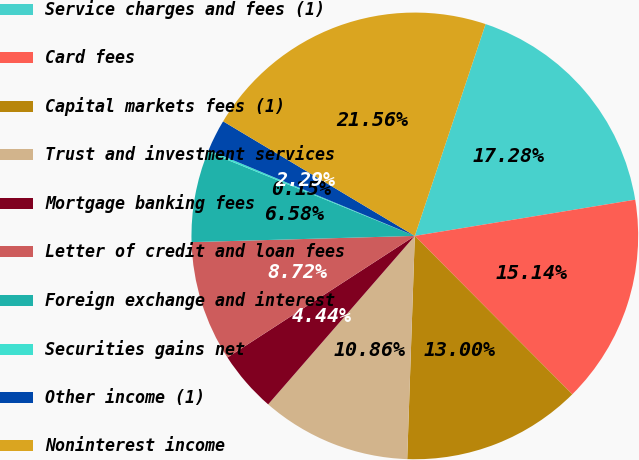<chart> <loc_0><loc_0><loc_500><loc_500><pie_chart><fcel>Service charges and fees (1)<fcel>Card fees<fcel>Capital markets fees (1)<fcel>Trust and investment services<fcel>Mortgage banking fees<fcel>Letter of credit and loan fees<fcel>Foreign exchange and interest<fcel>Securities gains net<fcel>Other income (1)<fcel>Noninterest income<nl><fcel>17.28%<fcel>15.14%<fcel>13.0%<fcel>10.86%<fcel>4.44%<fcel>8.72%<fcel>6.58%<fcel>0.15%<fcel>2.29%<fcel>21.56%<nl></chart> 